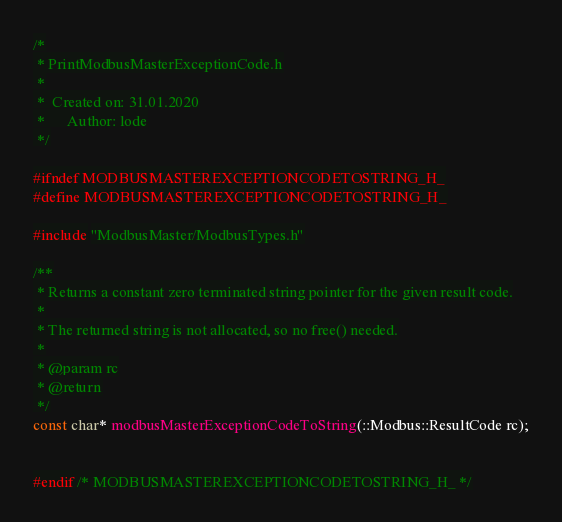<code> <loc_0><loc_0><loc_500><loc_500><_C_>/*
 * PrintModbusMasterExceptionCode.h
 *
 *  Created on: 31.01.2020
 *      Author: lode
 */

#ifndef MODBUSMASTEREXCEPTIONCODETOSTRING_H_
#define MODBUSMASTEREXCEPTIONCODETOSTRING_H_

#include "ModbusMaster/ModbusTypes.h"

/**
 * Returns a constant zero terminated string pointer for the given result code.
 *
 * The returned string is not allocated, so no free() needed.
 *
 * @param rc
 * @return
 */
const char* modbusMasterExceptionCodeToString(::Modbus::ResultCode rc);


#endif /* MODBUSMASTEREXCEPTIONCODETOSTRING_H_ */
</code> 